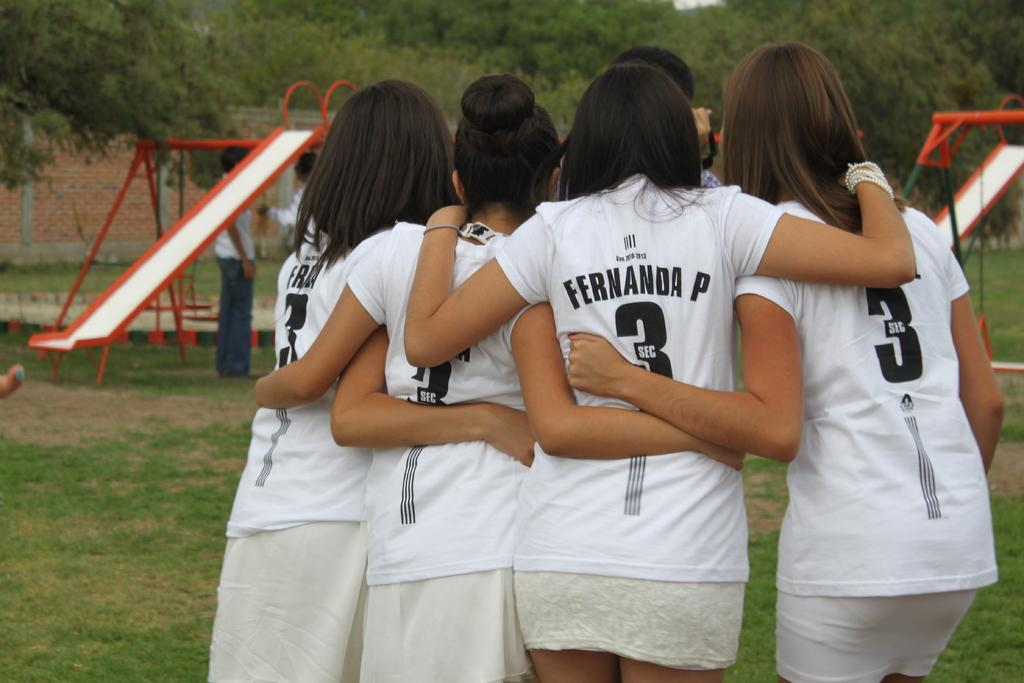<image>
Share a concise interpretation of the image provided. A group of girls wearing jerseys gather together, the girl in the middle reads Fernanda P. 